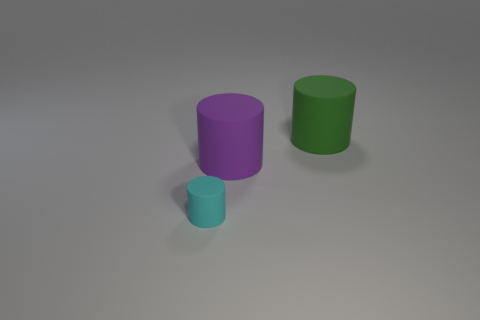Are there any other things that have the same size as the cyan rubber cylinder?
Your response must be concise. No. How many green objects are either small matte objects or large matte cylinders?
Offer a terse response. 1. Is there a small cyan matte cylinder in front of the rubber cylinder behind the large cylinder that is in front of the big green rubber cylinder?
Make the answer very short. Yes. How many tiny things are green cylinders or purple rubber objects?
Make the answer very short. 0. Are there fewer big brown cylinders than rubber objects?
Your answer should be very brief. Yes. Is there anything else that is the same color as the tiny matte cylinder?
Keep it short and to the point. No. Is the number of matte objects that are on the right side of the small cylinder the same as the number of things that are in front of the green object?
Provide a succinct answer. Yes. What number of other objects are the same size as the green thing?
Provide a succinct answer. 1. The cyan thing has what size?
Offer a very short reply. Small. Are there any other big things of the same shape as the purple object?
Provide a short and direct response. Yes. 